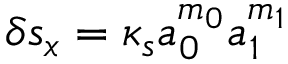Convert formula to latex. <formula><loc_0><loc_0><loc_500><loc_500>\delta s _ { x } = \kappa _ { s } a _ { 0 } ^ { m _ { 0 } } a _ { 1 } ^ { m _ { 1 } }</formula> 